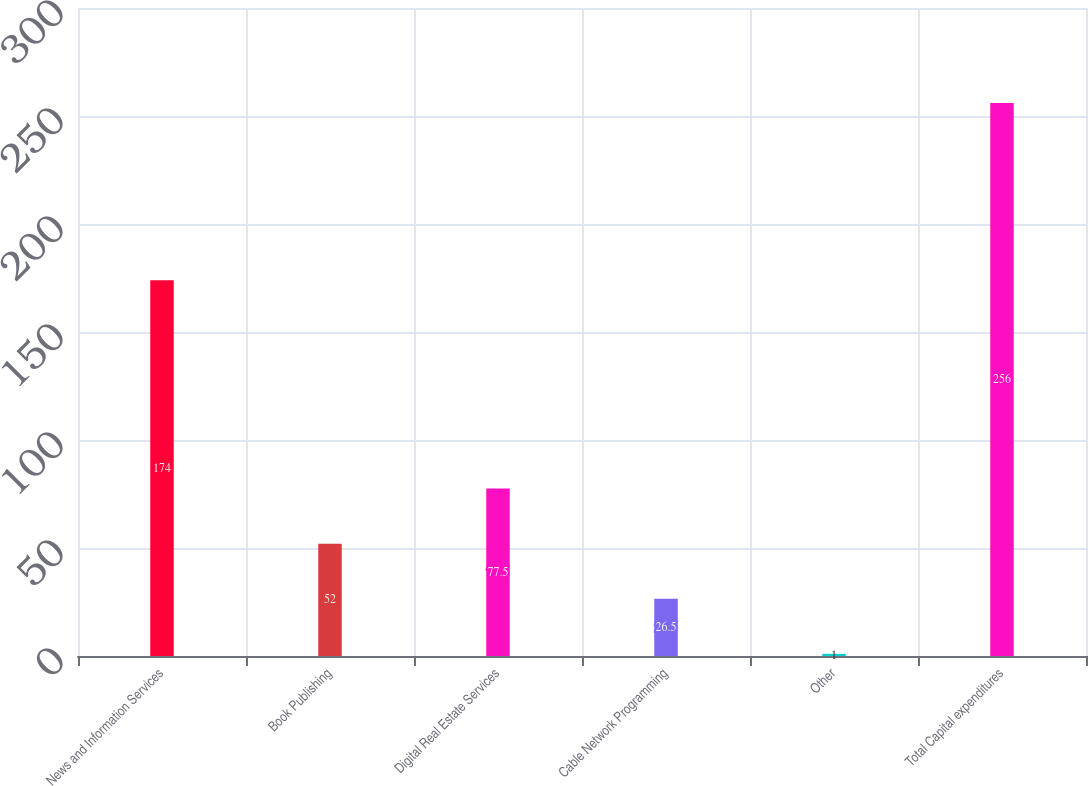Convert chart. <chart><loc_0><loc_0><loc_500><loc_500><bar_chart><fcel>News and Information Services<fcel>Book Publishing<fcel>Digital Real Estate Services<fcel>Cable Network Programming<fcel>Other<fcel>Total Capital expenditures<nl><fcel>174<fcel>52<fcel>77.5<fcel>26.5<fcel>1<fcel>256<nl></chart> 